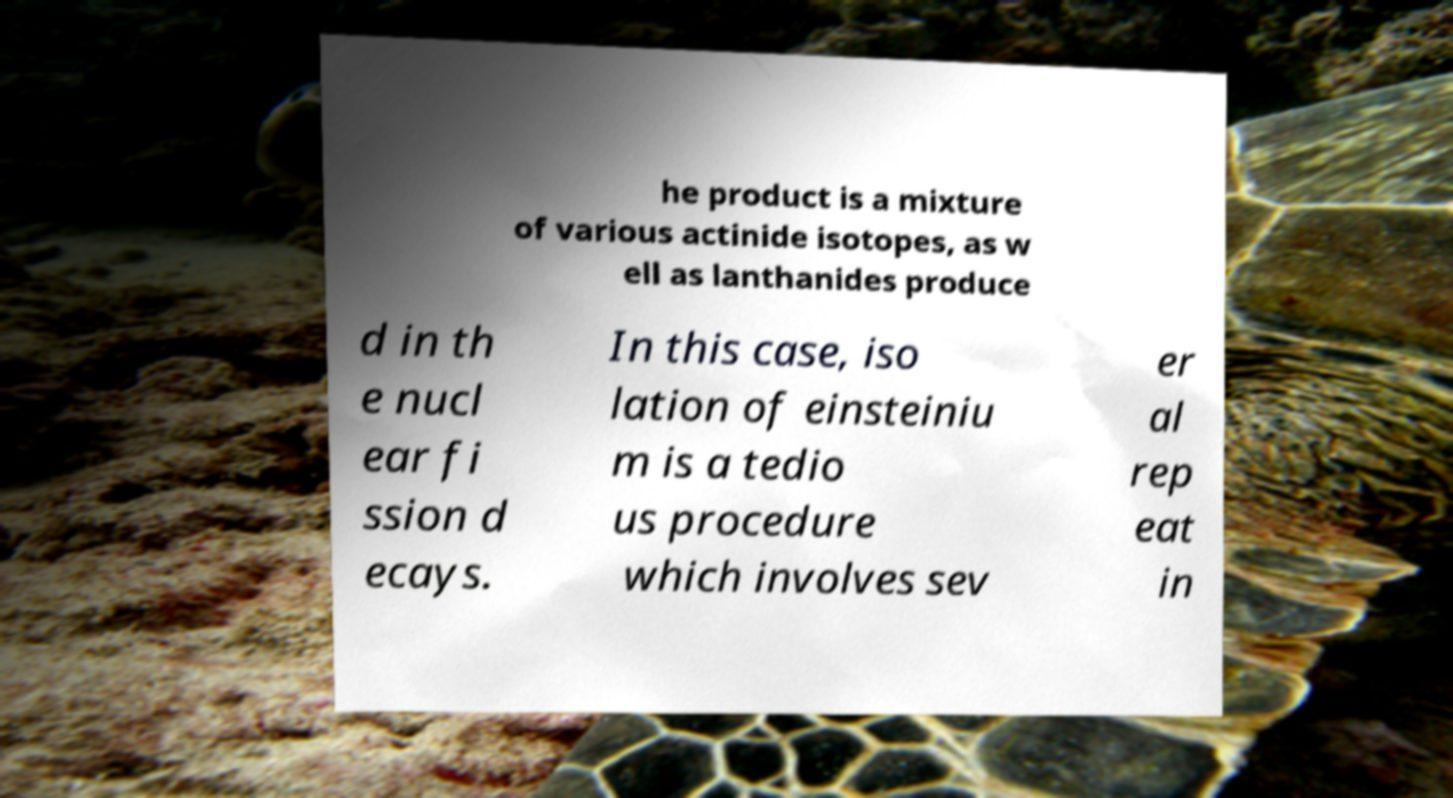Could you extract and type out the text from this image? he product is a mixture of various actinide isotopes, as w ell as lanthanides produce d in th e nucl ear fi ssion d ecays. In this case, iso lation of einsteiniu m is a tedio us procedure which involves sev er al rep eat in 